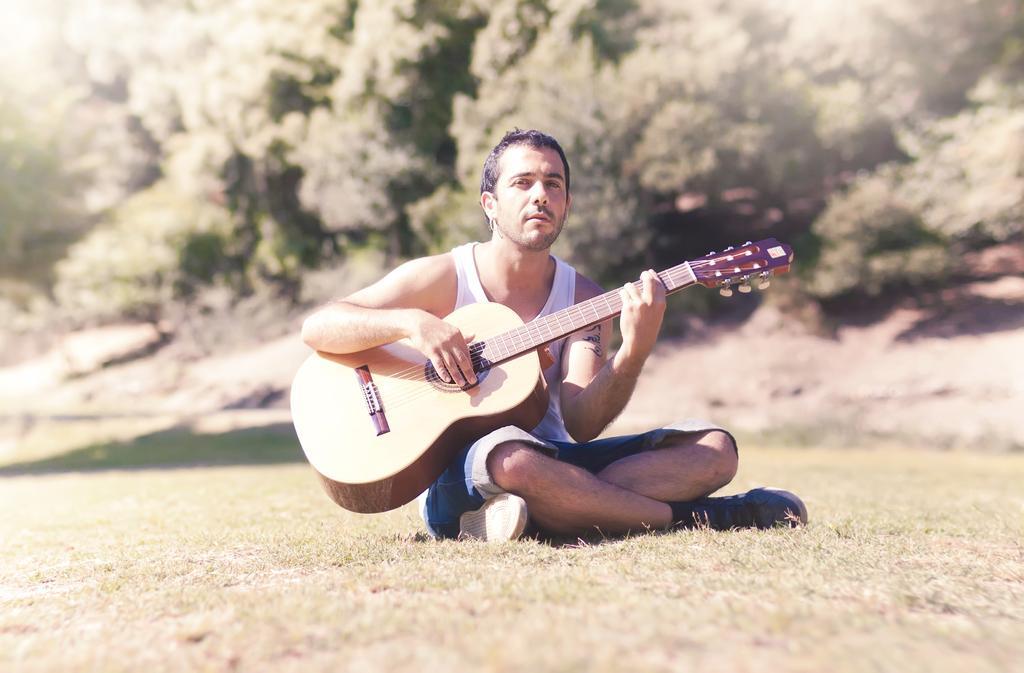In one or two sentences, can you explain what this image depicts? Here we can see a person is sitting on the ground, and holding a guitar in his hands, and at back here are the trees. 